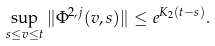<formula> <loc_0><loc_0><loc_500><loc_500>\sup _ { s \leq v \leq t } \| \Phi ^ { 2 , j } ( v , s ) \| \leq e ^ { K _ { 2 } ( t - s ) } .</formula> 